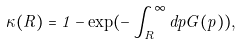Convert formula to latex. <formula><loc_0><loc_0><loc_500><loc_500>\kappa ( R ) = 1 - \exp ( - \int _ { R } ^ { \infty } d p G ( p ) ) ,</formula> 